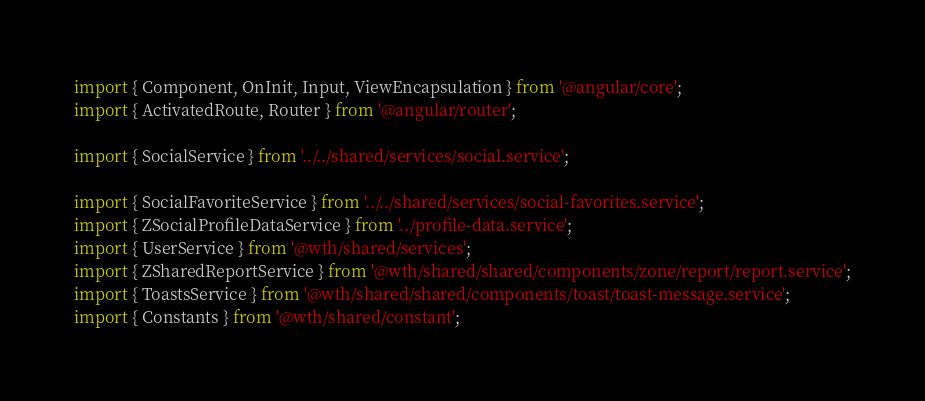Convert code to text. <code><loc_0><loc_0><loc_500><loc_500><_TypeScript_>import { Component, OnInit, Input, ViewEncapsulation } from '@angular/core';
import { ActivatedRoute, Router } from '@angular/router';

import { SocialService } from '../../shared/services/social.service';

import { SocialFavoriteService } from '../../shared/services/social-favorites.service';
import { ZSocialProfileDataService } from '../profile-data.service';
import { UserService } from '@wth/shared/services';
import { ZSharedReportService } from '@wth/shared/shared/components/zone/report/report.service';
import { ToastsService } from '@wth/shared/shared/components/toast/toast-message.service';
import { Constants } from '@wth/shared/constant';</code> 